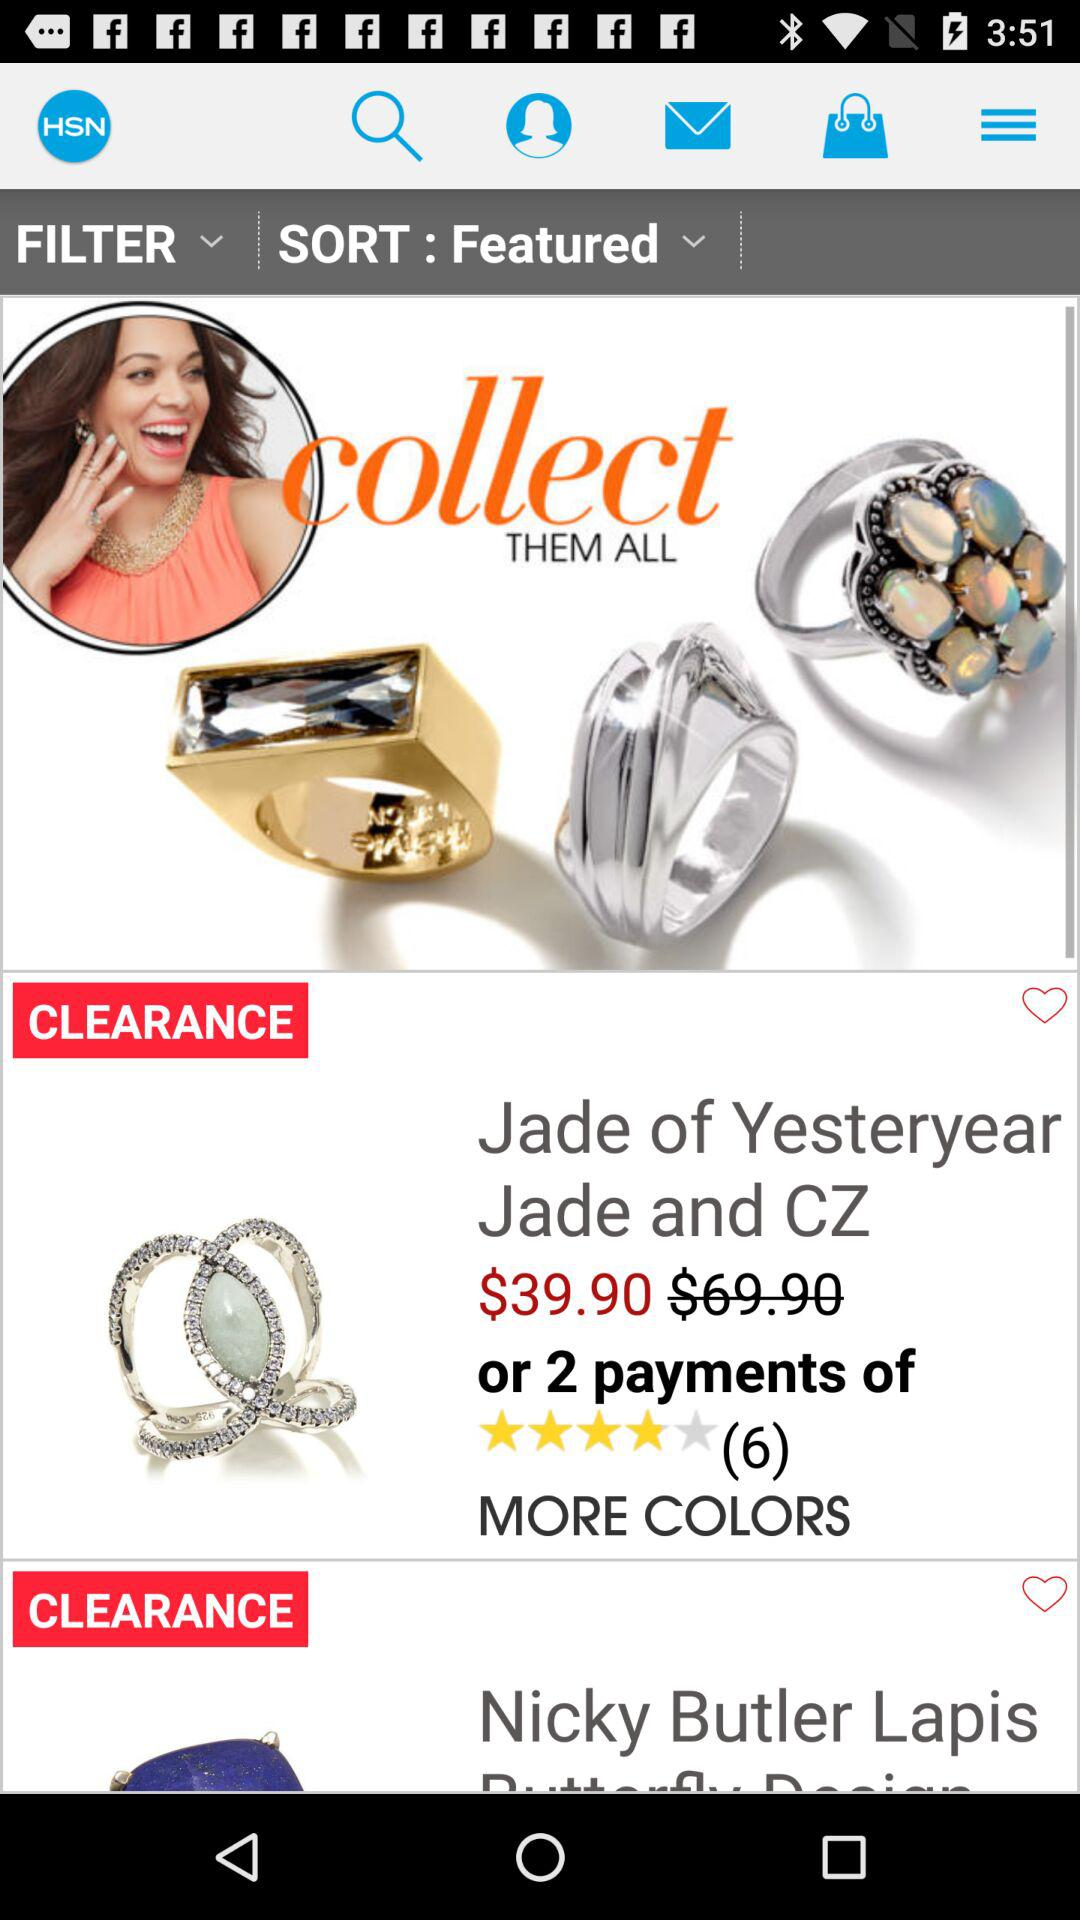What is the cost of "Jade of Yesteryear Jade and CZ"? The cost is $39.90. 